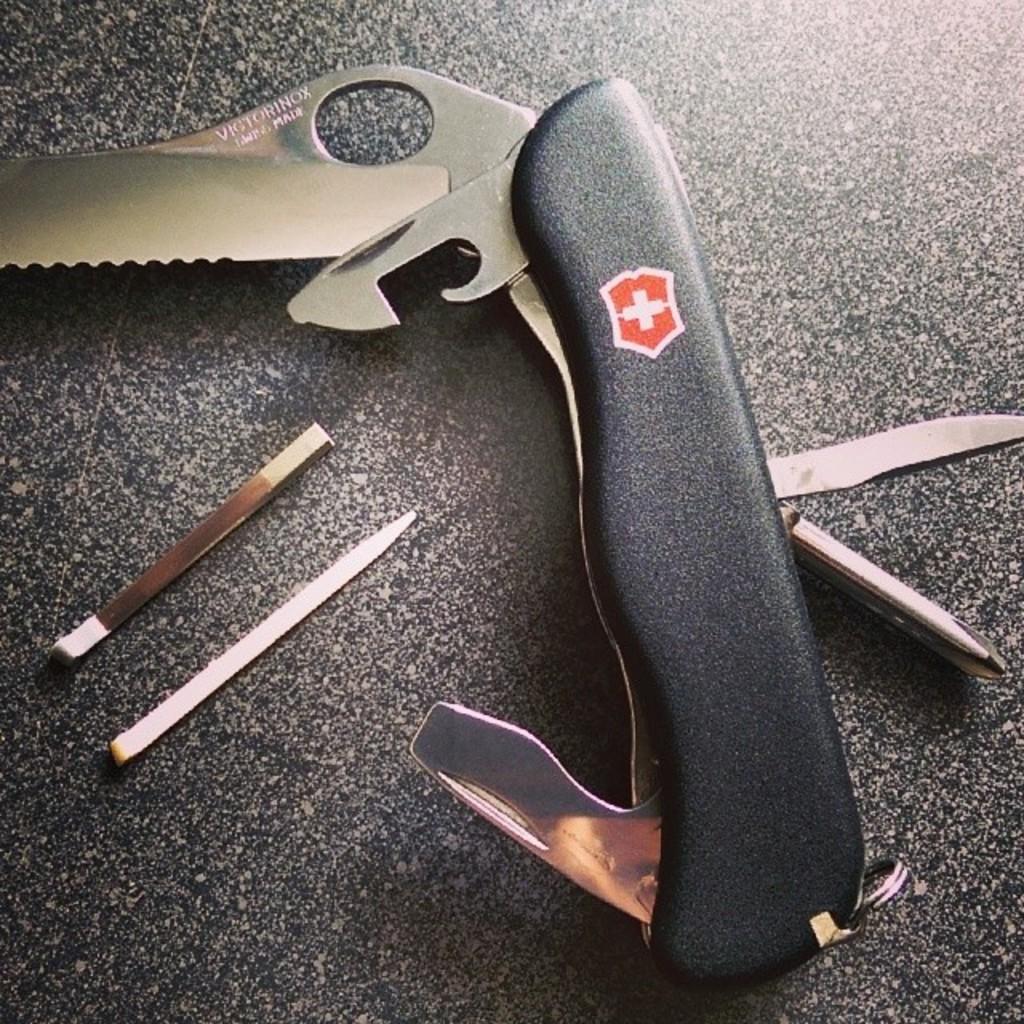Please provide a concise description of this image. In this picture there are wooden objects and a knife like object, on a black surface. 